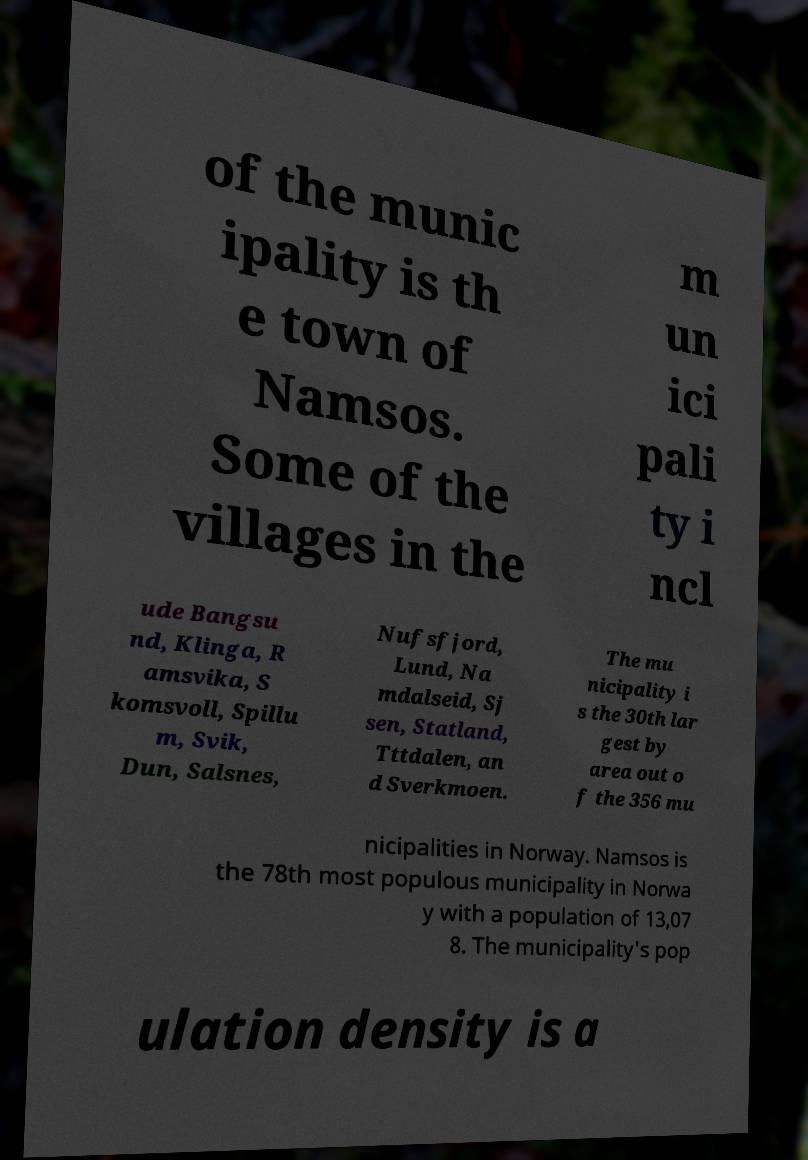Can you accurately transcribe the text from the provided image for me? of the munic ipality is th e town of Namsos. Some of the villages in the m un ici pali ty i ncl ude Bangsu nd, Klinga, R amsvika, S komsvoll, Spillu m, Svik, Dun, Salsnes, Nufsfjord, Lund, Na mdalseid, Sj sen, Statland, Tttdalen, an d Sverkmoen. The mu nicipality i s the 30th lar gest by area out o f the 356 mu nicipalities in Norway. Namsos is the 78th most populous municipality in Norwa y with a population of 13,07 8. The municipality's pop ulation density is a 